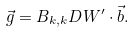Convert formula to latex. <formula><loc_0><loc_0><loc_500><loc_500>\vec { g } = B _ { k , k } D W ^ { \prime } \cdot \vec { b } .</formula> 